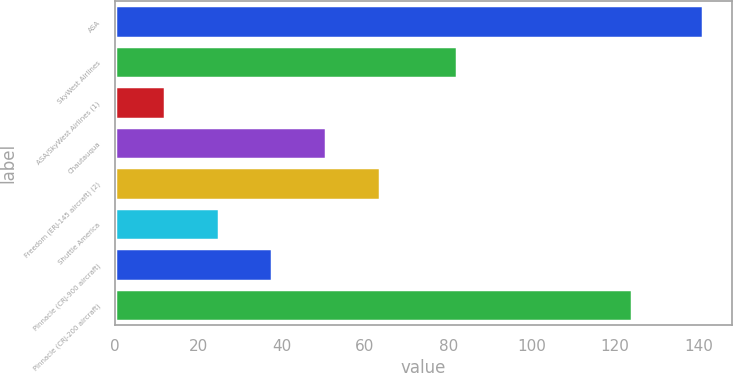Convert chart to OTSL. <chart><loc_0><loc_0><loc_500><loc_500><bar_chart><fcel>ASA<fcel>SkyWest Airlines<fcel>ASA/SkyWest Airlines (1)<fcel>Chautauqua<fcel>Freedom (ERJ-145 aircraft) (2)<fcel>Shuttle America<fcel>Pinnacle (CRJ-900 aircraft)<fcel>Pinnacle (CRJ-200 aircraft)<nl><fcel>141<fcel>82<fcel>12<fcel>50.7<fcel>63.6<fcel>24.9<fcel>37.8<fcel>124<nl></chart> 